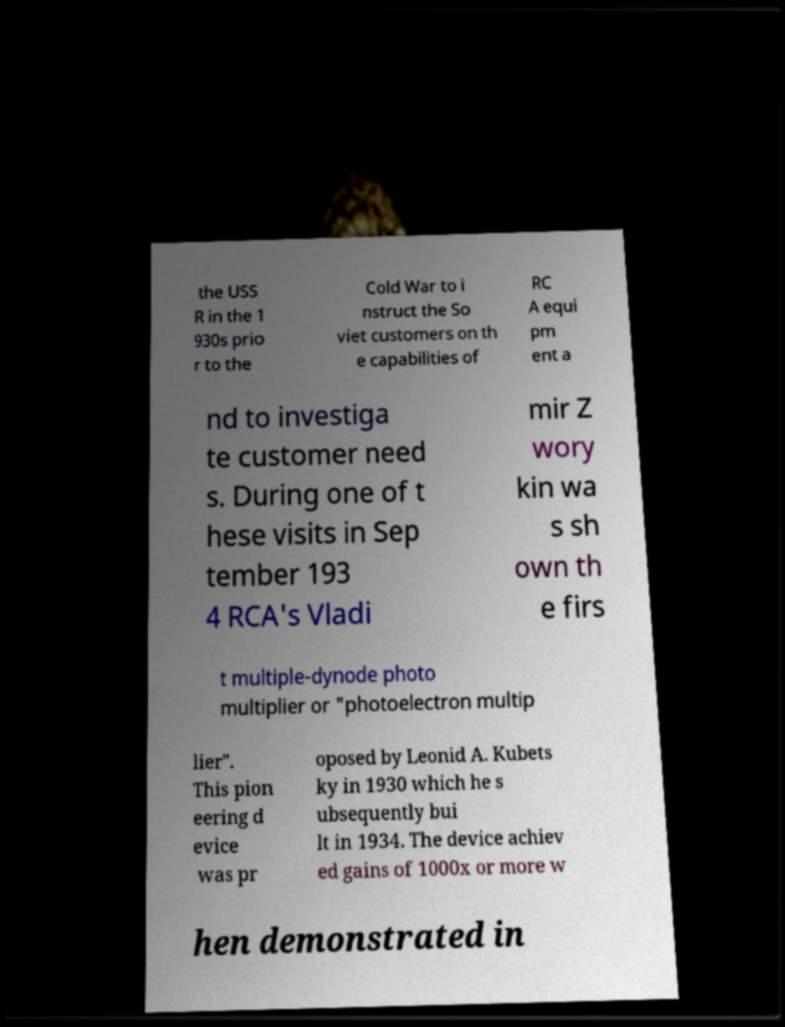Please read and relay the text visible in this image. What does it say? the USS R in the 1 930s prio r to the Cold War to i nstruct the So viet customers on th e capabilities of RC A equi pm ent a nd to investiga te customer need s. During one of t hese visits in Sep tember 193 4 RCA's Vladi mir Z wory kin wa s sh own th e firs t multiple-dynode photo multiplier or "photoelectron multip lier". This pion eering d evice was pr oposed by Leonid A. Kubets ky in 1930 which he s ubsequently bui lt in 1934. The device achiev ed gains of 1000x or more w hen demonstrated in 